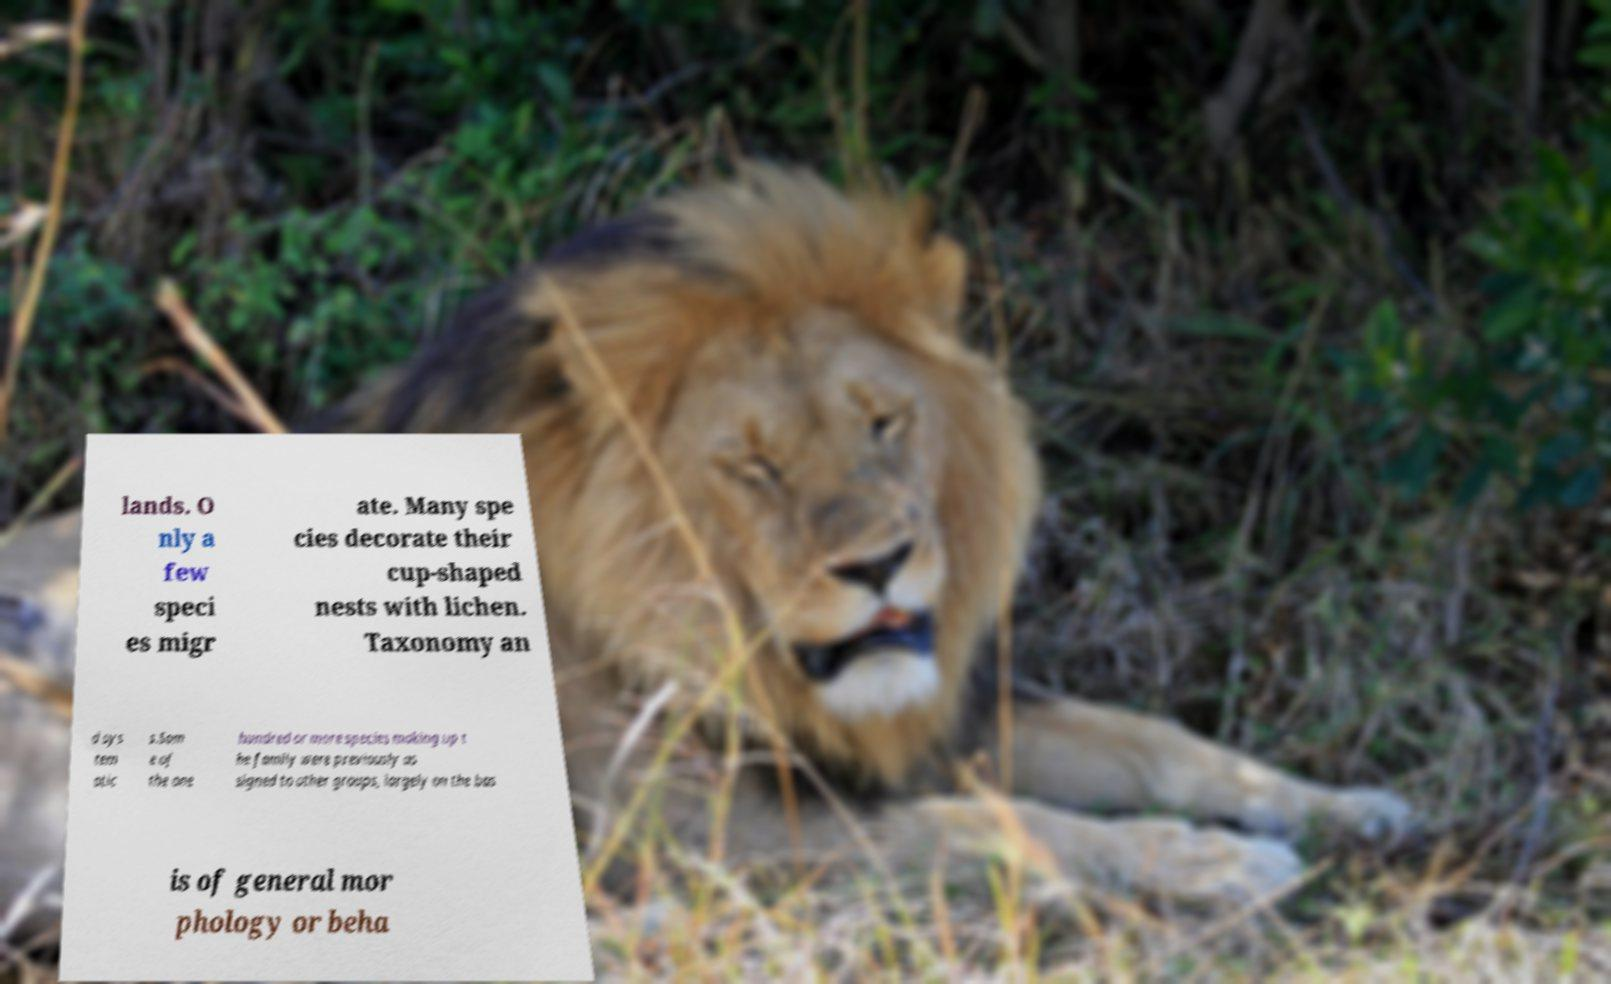Can you accurately transcribe the text from the provided image for me? lands. O nly a few speci es migr ate. Many spe cies decorate their cup-shaped nests with lichen. Taxonomy an d sys tem atic s.Som e of the one hundred or more species making up t he family were previously as signed to other groups, largely on the bas is of general mor phology or beha 